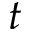Convert formula to latex. <formula><loc_0><loc_0><loc_500><loc_500>t</formula> 